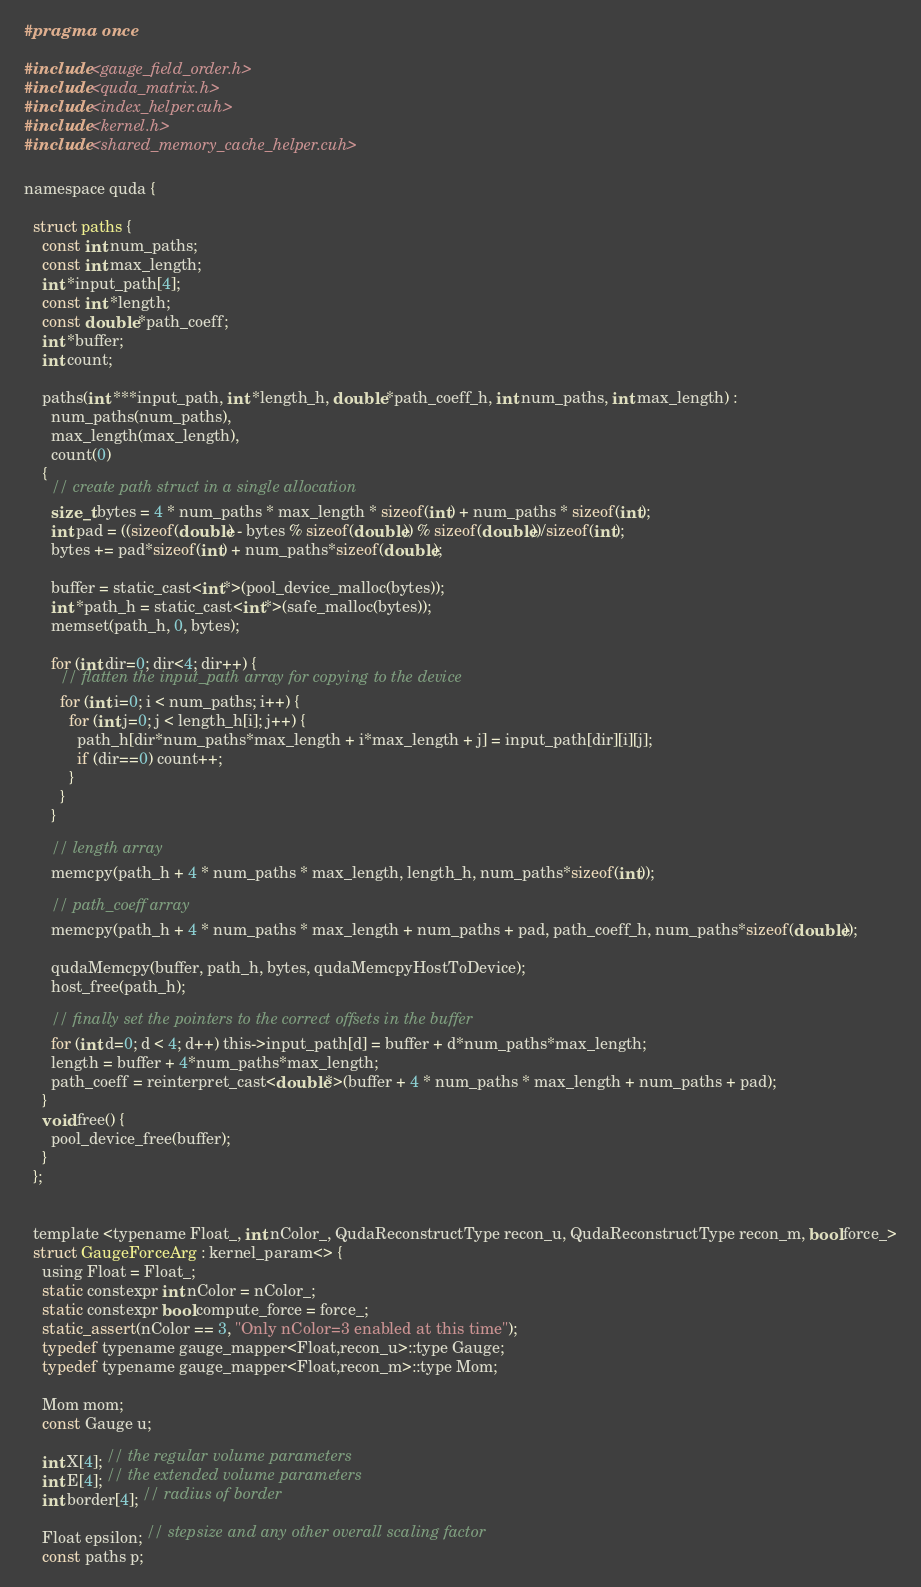Convert code to text. <code><loc_0><loc_0><loc_500><loc_500><_Cuda_>#pragma once

#include <gauge_field_order.h>
#include <quda_matrix.h>
#include <index_helper.cuh>
#include <kernel.h>
#include <shared_memory_cache_helper.cuh>

namespace quda {

  struct paths {
    const int num_paths;
    const int max_length;
    int *input_path[4];
    const int *length;
    const double *path_coeff;
    int *buffer;
    int count;

    paths(int ***input_path, int *length_h, double *path_coeff_h, int num_paths, int max_length) :
      num_paths(num_paths),
      max_length(max_length),
      count(0)
    {
      // create path struct in a single allocation
      size_t bytes = 4 * num_paths * max_length * sizeof(int) + num_paths * sizeof(int);
      int pad = ((sizeof(double) - bytes % sizeof(double)) % sizeof(double))/sizeof(int);
      bytes += pad*sizeof(int) + num_paths*sizeof(double);

      buffer = static_cast<int*>(pool_device_malloc(bytes));
      int *path_h = static_cast<int*>(safe_malloc(bytes));
      memset(path_h, 0, bytes);

      for (int dir=0; dir<4; dir++) {
        // flatten the input_path array for copying to the device
        for (int i=0; i < num_paths; i++) {
          for (int j=0; j < length_h[i]; j++) {
            path_h[dir*num_paths*max_length + i*max_length + j] = input_path[dir][i][j];
            if (dir==0) count++;
          }
        }
      }

      // length array
      memcpy(path_h + 4 * num_paths * max_length, length_h, num_paths*sizeof(int));

      // path_coeff array
      memcpy(path_h + 4 * num_paths * max_length + num_paths + pad, path_coeff_h, num_paths*sizeof(double));

      qudaMemcpy(buffer, path_h, bytes, qudaMemcpyHostToDevice);
      host_free(path_h);

      // finally set the pointers to the correct offsets in the buffer
      for (int d=0; d < 4; d++) this->input_path[d] = buffer + d*num_paths*max_length;
      length = buffer + 4*num_paths*max_length;
      path_coeff = reinterpret_cast<double*>(buffer + 4 * num_paths * max_length + num_paths + pad);
    }
    void free() {
      pool_device_free(buffer);
    }
  };


  template <typename Float_, int nColor_, QudaReconstructType recon_u, QudaReconstructType recon_m, bool force_>
  struct GaugeForceArg : kernel_param<> {
    using Float = Float_;
    static constexpr int nColor = nColor_;
    static constexpr bool compute_force = force_;
    static_assert(nColor == 3, "Only nColor=3 enabled at this time");
    typedef typename gauge_mapper<Float,recon_u>::type Gauge;
    typedef typename gauge_mapper<Float,recon_m>::type Mom;

    Mom mom;
    const Gauge u;

    int X[4]; // the regular volume parameters
    int E[4]; // the extended volume parameters
    int border[4]; // radius of border

    Float epsilon; // stepsize and any other overall scaling factor
    const paths p;
</code> 